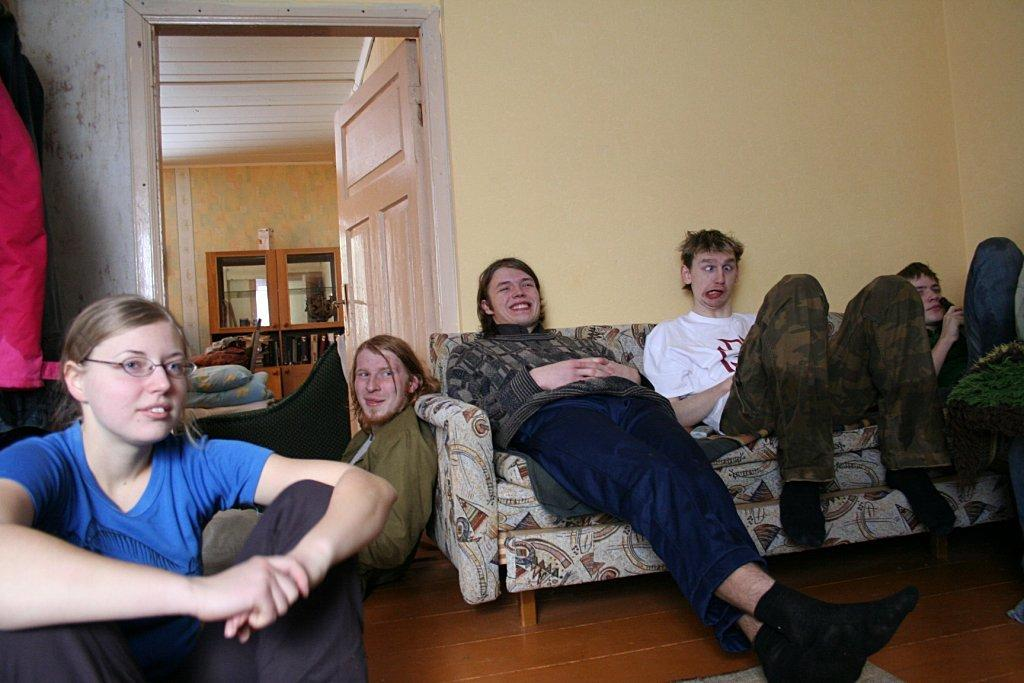How many people are present in the image? There are five persons in the image. What is located in the front of the image? There is a sofa in the front of the image. What is at the bottom of the image? There is a floor at the bottom of the image. What can be seen in the background of the image? There is a wall in the background of the image. Is there any entrance or exit associated with the wall in the background? Yes, there is a door associated with the wall in the background. What type of clam is sitting on the sofa in the image? There is no clam present in the image; it features five persons and a sofa. What is the fifth person doing in the image? The provided facts do not specify the actions or activities of the five persons in the image. 